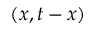<formula> <loc_0><loc_0><loc_500><loc_500>( x , t - x )</formula> 